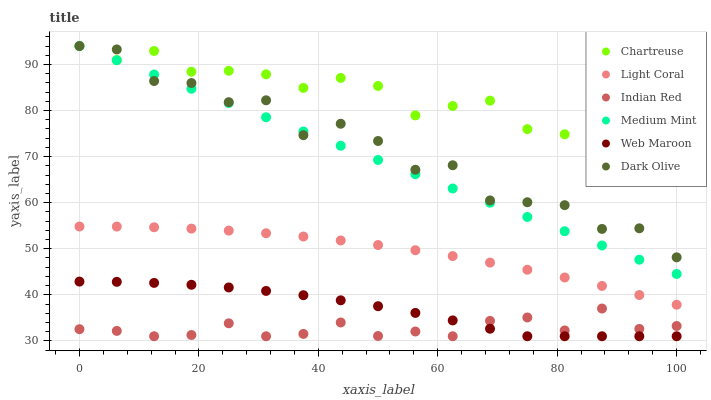Does Indian Red have the minimum area under the curve?
Answer yes or no. Yes. Does Chartreuse have the maximum area under the curve?
Answer yes or no. Yes. Does Dark Olive have the minimum area under the curve?
Answer yes or no. No. Does Dark Olive have the maximum area under the curve?
Answer yes or no. No. Is Medium Mint the smoothest?
Answer yes or no. Yes. Is Dark Olive the roughest?
Answer yes or no. Yes. Is Web Maroon the smoothest?
Answer yes or no. No. Is Web Maroon the roughest?
Answer yes or no. No. Does Web Maroon have the lowest value?
Answer yes or no. Yes. Does Dark Olive have the lowest value?
Answer yes or no. No. Does Chartreuse have the highest value?
Answer yes or no. Yes. Does Web Maroon have the highest value?
Answer yes or no. No. Is Indian Red less than Light Coral?
Answer yes or no. Yes. Is Dark Olive greater than Web Maroon?
Answer yes or no. Yes. Does Medium Mint intersect Chartreuse?
Answer yes or no. Yes. Is Medium Mint less than Chartreuse?
Answer yes or no. No. Is Medium Mint greater than Chartreuse?
Answer yes or no. No. Does Indian Red intersect Light Coral?
Answer yes or no. No. 